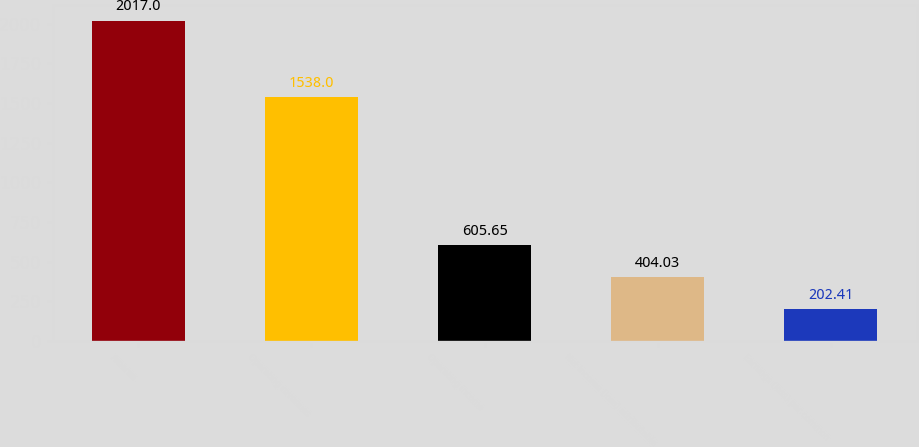<chart> <loc_0><loc_0><loc_500><loc_500><bar_chart><fcel>Ameren<fcel>Operating revenues<fcel>Operating income<fcel>Net income (loss) attributable<fcel>Earnings (loss) per common<nl><fcel>2017<fcel>1538<fcel>605.65<fcel>404.03<fcel>202.41<nl></chart> 